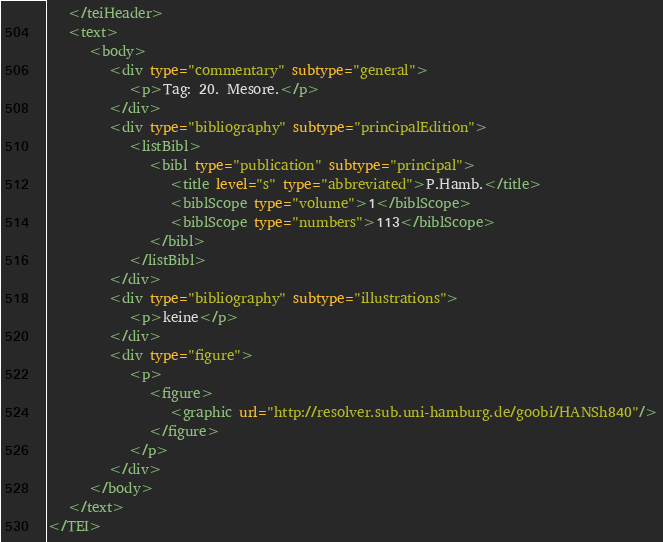<code> <loc_0><loc_0><loc_500><loc_500><_XML_>   </teiHeader>
   <text>
      <body>
         <div type="commentary" subtype="general">
            <p>Tag: 20. Mesore.</p>
         </div>
         <div type="bibliography" subtype="principalEdition">
            <listBibl>
               <bibl type="publication" subtype="principal">
                  <title level="s" type="abbreviated">P.Hamb.</title>
                  <biblScope type="volume">1</biblScope>
                  <biblScope type="numbers">113</biblScope>
               </bibl>
            </listBibl>
         </div>
         <div type="bibliography" subtype="illustrations">
            <p>keine</p>
         </div>
         <div type="figure">
            <p>
               <figure>
                  <graphic url="http://resolver.sub.uni-hamburg.de/goobi/HANSh840"/>
               </figure>
            </p>
         </div>
      </body>
   </text>
</TEI>
</code> 